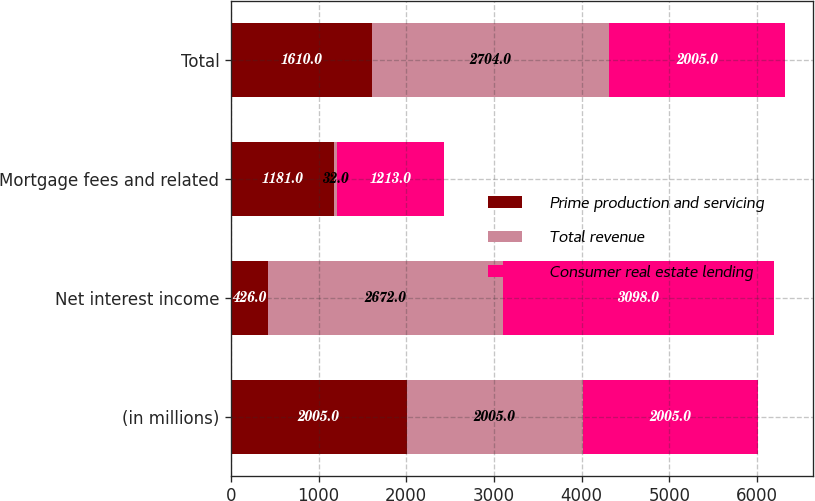Convert chart. <chart><loc_0><loc_0><loc_500><loc_500><stacked_bar_chart><ecel><fcel>(in millions)<fcel>Net interest income<fcel>Mortgage fees and related<fcel>Total<nl><fcel>Prime production and servicing<fcel>2005<fcel>426<fcel>1181<fcel>1610<nl><fcel>Total revenue<fcel>2005<fcel>2672<fcel>32<fcel>2704<nl><fcel>Consumer real estate lending<fcel>2005<fcel>3098<fcel>1213<fcel>2005<nl></chart> 